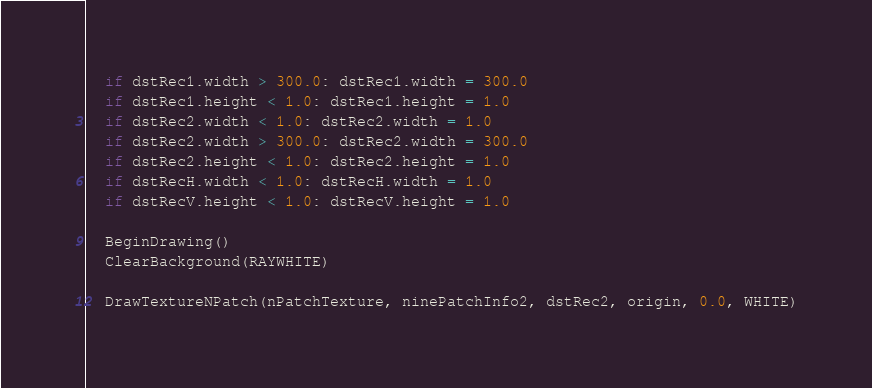<code> <loc_0><loc_0><loc_500><loc_500><_Nim_>  if dstRec1.width > 300.0: dstRec1.width = 300.0
  if dstRec1.height < 1.0: dstRec1.height = 1.0
  if dstRec2.width < 1.0: dstRec2.width = 1.0
  if dstRec2.width > 300.0: dstRec2.width = 300.0
  if dstRec2.height < 1.0: dstRec2.height = 1.0
  if dstRecH.width < 1.0: dstRecH.width = 1.0
  if dstRecV.height < 1.0: dstRecV.height = 1.0

  BeginDrawing()
  ClearBackground(RAYWHITE)

  DrawTextureNPatch(nPatchTexture, ninePatchInfo2, dstRec2, origin, 0.0, WHITE)</code> 